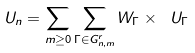Convert formula to latex. <formula><loc_0><loc_0><loc_500><loc_500>\ U _ { n } = \sum _ { m \geq 0 } \sum _ { \Gamma \in G ^ { r } _ { n , m } } W _ { \Gamma } \times \ U _ { \Gamma }</formula> 